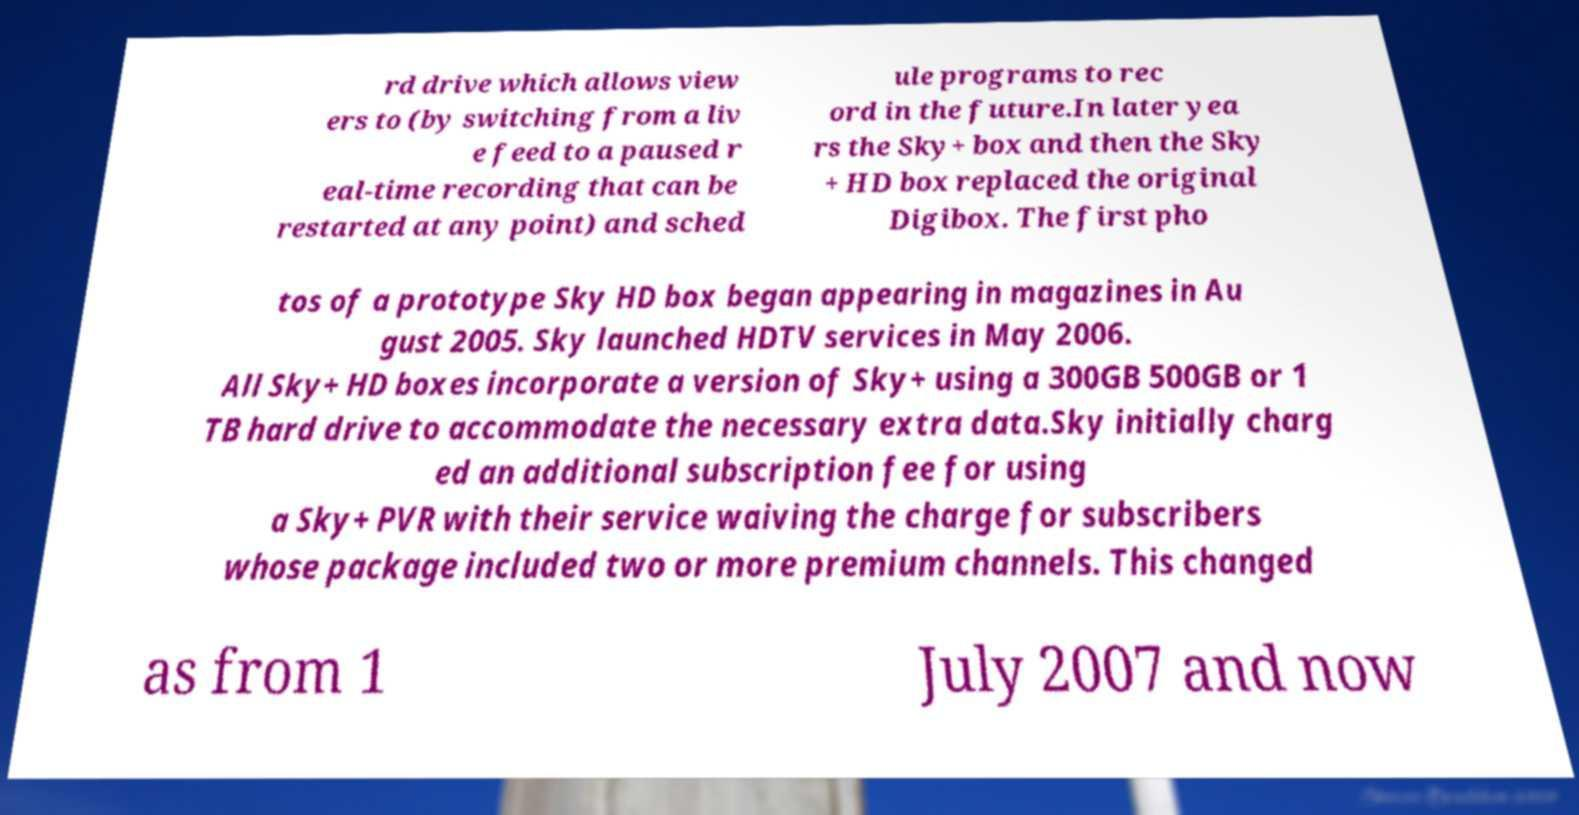What messages or text are displayed in this image? I need them in a readable, typed format. rd drive which allows view ers to (by switching from a liv e feed to a paused r eal-time recording that can be restarted at any point) and sched ule programs to rec ord in the future.In later yea rs the Sky+ box and then the Sky + HD box replaced the original Digibox. The first pho tos of a prototype Sky HD box began appearing in magazines in Au gust 2005. Sky launched HDTV services in May 2006. All Sky+ HD boxes incorporate a version of Sky+ using a 300GB 500GB or 1 TB hard drive to accommodate the necessary extra data.Sky initially charg ed an additional subscription fee for using a Sky+ PVR with their service waiving the charge for subscribers whose package included two or more premium channels. This changed as from 1 July 2007 and now 